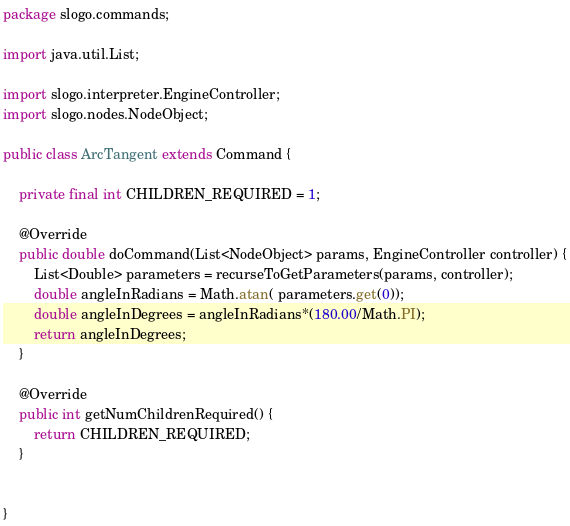Convert code to text. <code><loc_0><loc_0><loc_500><loc_500><_Java_>package slogo.commands;

import java.util.List;

import slogo.interpreter.EngineController;
import slogo.nodes.NodeObject;

public class ArcTangent extends Command {

	private final int CHILDREN_REQUIRED = 1;

	@Override
	public double doCommand(List<NodeObject> params, EngineController controller) {
		List<Double> parameters = recurseToGetParameters(params, controller);
		double angleInRadians = Math.atan( parameters.get(0));
		double angleInDegrees = angleInRadians*(180.00/Math.PI);
		return angleInDegrees;
	}

	@Override
	public int getNumChildrenRequired() {
		return CHILDREN_REQUIRED;
	}


}
</code> 